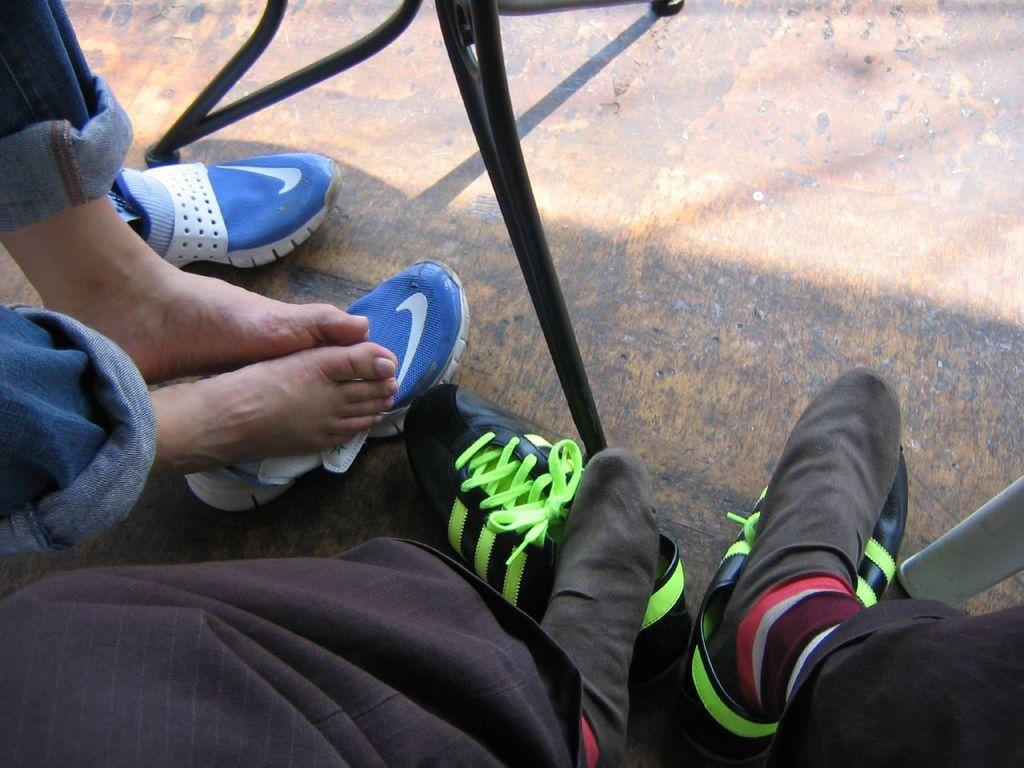What can be seen at the bottom of the image? There are legs of people visible in the image. What is covering the legs of the people? There are shoes visible in the image. What colors can be seen among the shoes? The color of some shoes is blue, and the color of some shoes is black. What type of kitten is playing with a substance in the image? There is no kitten or substance present in the image. 